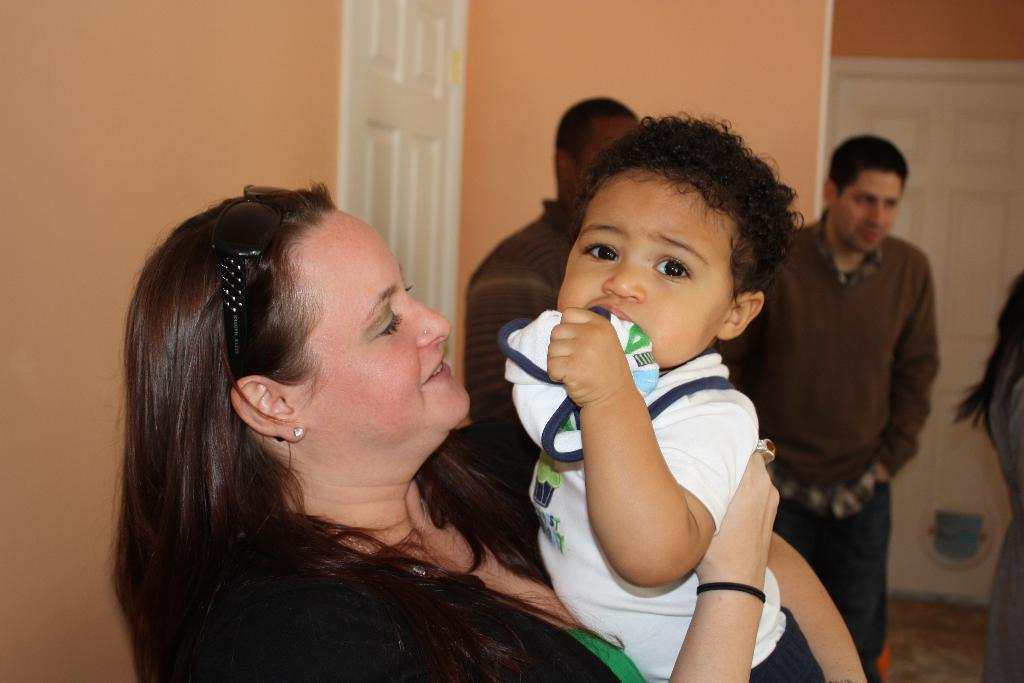Who is the main subject in the image? There is a woman in the image. What is the woman doing in the image? The woman is carrying a kid in her hand. Can you describe the woman's appearance? The woman is wearing sunglasses on her head. What else can be seen in the background of the image? There are other people standing in the background of the image. Are there any architectural features visible in the image? Yes, there are doors visible in the image. What type of orange is the woman holding in the image? There is no orange present in the image; the woman is carrying a kid in her hand. 